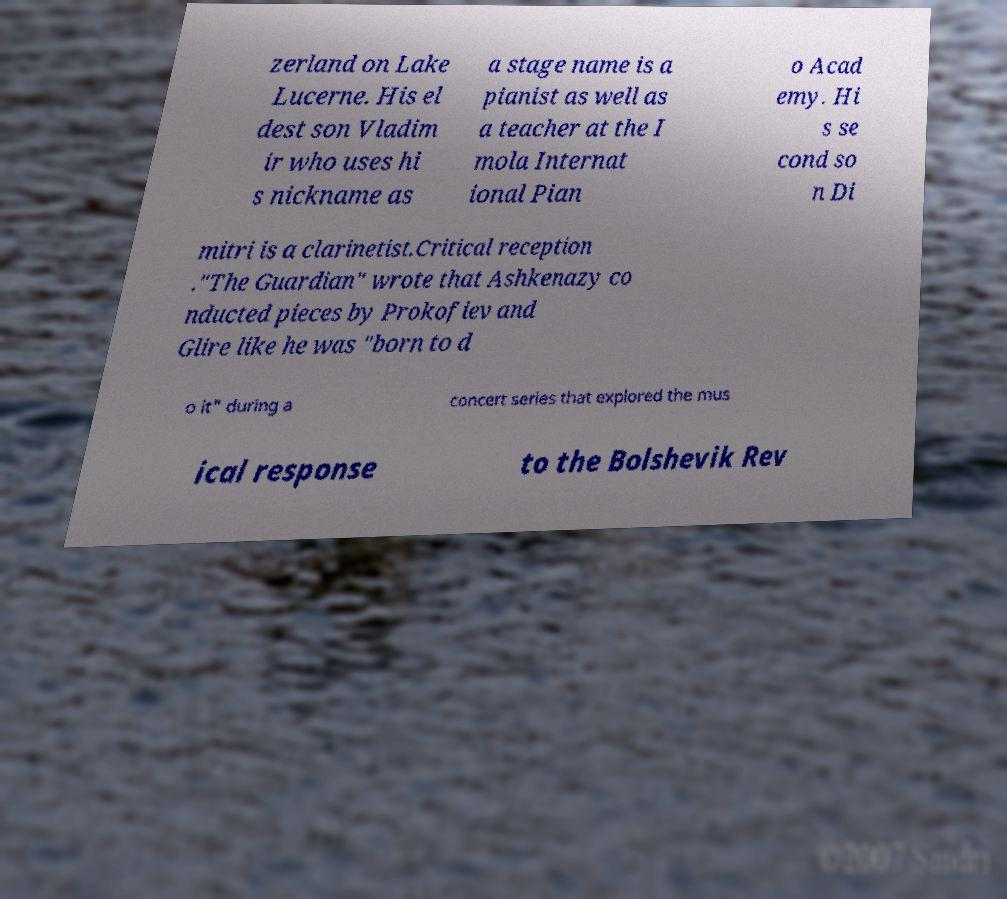Please read and relay the text visible in this image. What does it say? zerland on Lake Lucerne. His el dest son Vladim ir who uses hi s nickname as a stage name is a pianist as well as a teacher at the I mola Internat ional Pian o Acad emy. Hi s se cond so n Di mitri is a clarinetist.Critical reception ."The Guardian" wrote that Ashkenazy co nducted pieces by Prokofiev and Glire like he was "born to d o it" during a concert series that explored the mus ical response to the Bolshevik Rev 